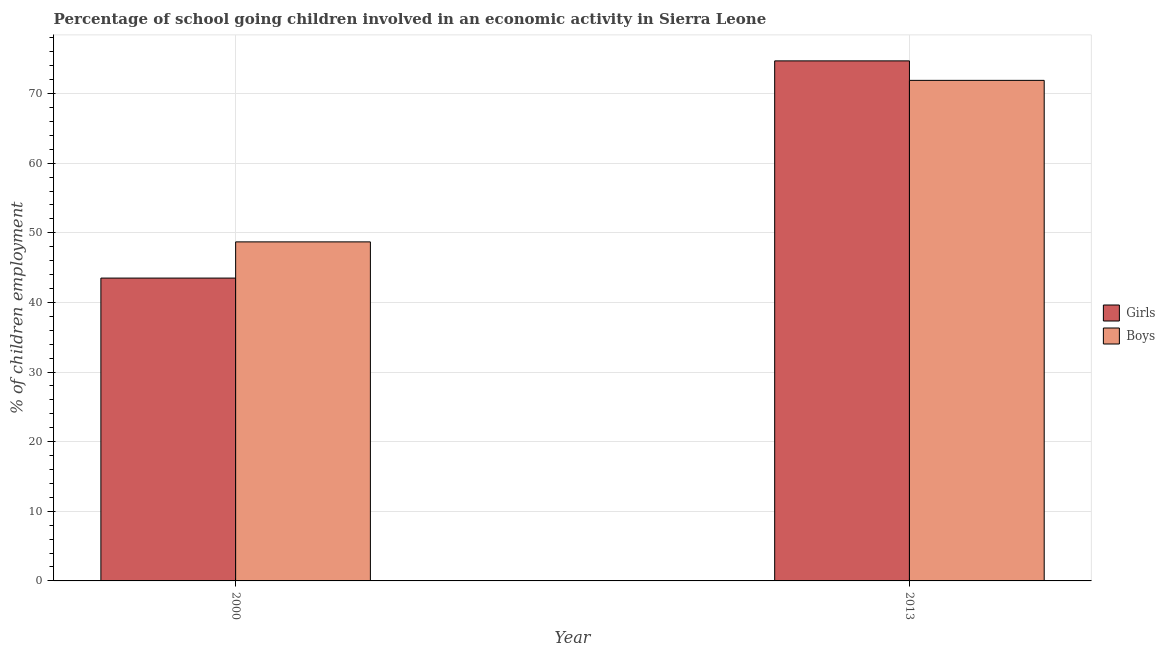How many different coloured bars are there?
Keep it short and to the point. 2. Are the number of bars on each tick of the X-axis equal?
Provide a short and direct response. Yes. How many bars are there on the 1st tick from the left?
Your answer should be very brief. 2. What is the percentage of school going girls in 2000?
Your answer should be very brief. 43.5. Across all years, what is the maximum percentage of school going boys?
Your response must be concise. 71.9. Across all years, what is the minimum percentage of school going boys?
Provide a short and direct response. 48.7. What is the total percentage of school going boys in the graph?
Ensure brevity in your answer.  120.6. What is the difference between the percentage of school going girls in 2000 and that in 2013?
Provide a short and direct response. -31.2. What is the difference between the percentage of school going girls in 2013 and the percentage of school going boys in 2000?
Your answer should be very brief. 31.2. What is the average percentage of school going boys per year?
Provide a short and direct response. 60.3. What is the ratio of the percentage of school going girls in 2000 to that in 2013?
Provide a short and direct response. 0.58. What does the 2nd bar from the left in 2013 represents?
Ensure brevity in your answer.  Boys. What does the 2nd bar from the right in 2013 represents?
Provide a short and direct response. Girls. Are all the bars in the graph horizontal?
Provide a short and direct response. No. How many years are there in the graph?
Make the answer very short. 2. What is the difference between two consecutive major ticks on the Y-axis?
Provide a succinct answer. 10. Are the values on the major ticks of Y-axis written in scientific E-notation?
Your answer should be very brief. No. Does the graph contain any zero values?
Your response must be concise. No. How many legend labels are there?
Make the answer very short. 2. How are the legend labels stacked?
Give a very brief answer. Vertical. What is the title of the graph?
Your answer should be very brief. Percentage of school going children involved in an economic activity in Sierra Leone. Does "Crop" appear as one of the legend labels in the graph?
Your response must be concise. No. What is the label or title of the Y-axis?
Your answer should be compact. % of children employment. What is the % of children employment in Girls in 2000?
Give a very brief answer. 43.5. What is the % of children employment in Boys in 2000?
Make the answer very short. 48.7. What is the % of children employment of Girls in 2013?
Make the answer very short. 74.7. What is the % of children employment in Boys in 2013?
Provide a succinct answer. 71.9. Across all years, what is the maximum % of children employment of Girls?
Offer a terse response. 74.7. Across all years, what is the maximum % of children employment of Boys?
Give a very brief answer. 71.9. Across all years, what is the minimum % of children employment in Girls?
Your answer should be compact. 43.5. Across all years, what is the minimum % of children employment of Boys?
Your answer should be compact. 48.7. What is the total % of children employment of Girls in the graph?
Give a very brief answer. 118.2. What is the total % of children employment in Boys in the graph?
Offer a terse response. 120.6. What is the difference between the % of children employment of Girls in 2000 and that in 2013?
Provide a short and direct response. -31.2. What is the difference between the % of children employment of Boys in 2000 and that in 2013?
Give a very brief answer. -23.2. What is the difference between the % of children employment of Girls in 2000 and the % of children employment of Boys in 2013?
Offer a very short reply. -28.4. What is the average % of children employment in Girls per year?
Provide a short and direct response. 59.1. What is the average % of children employment of Boys per year?
Keep it short and to the point. 60.3. What is the ratio of the % of children employment in Girls in 2000 to that in 2013?
Your answer should be very brief. 0.58. What is the ratio of the % of children employment in Boys in 2000 to that in 2013?
Give a very brief answer. 0.68. What is the difference between the highest and the second highest % of children employment of Girls?
Your response must be concise. 31.2. What is the difference between the highest and the second highest % of children employment in Boys?
Provide a succinct answer. 23.2. What is the difference between the highest and the lowest % of children employment of Girls?
Make the answer very short. 31.2. What is the difference between the highest and the lowest % of children employment of Boys?
Your response must be concise. 23.2. 